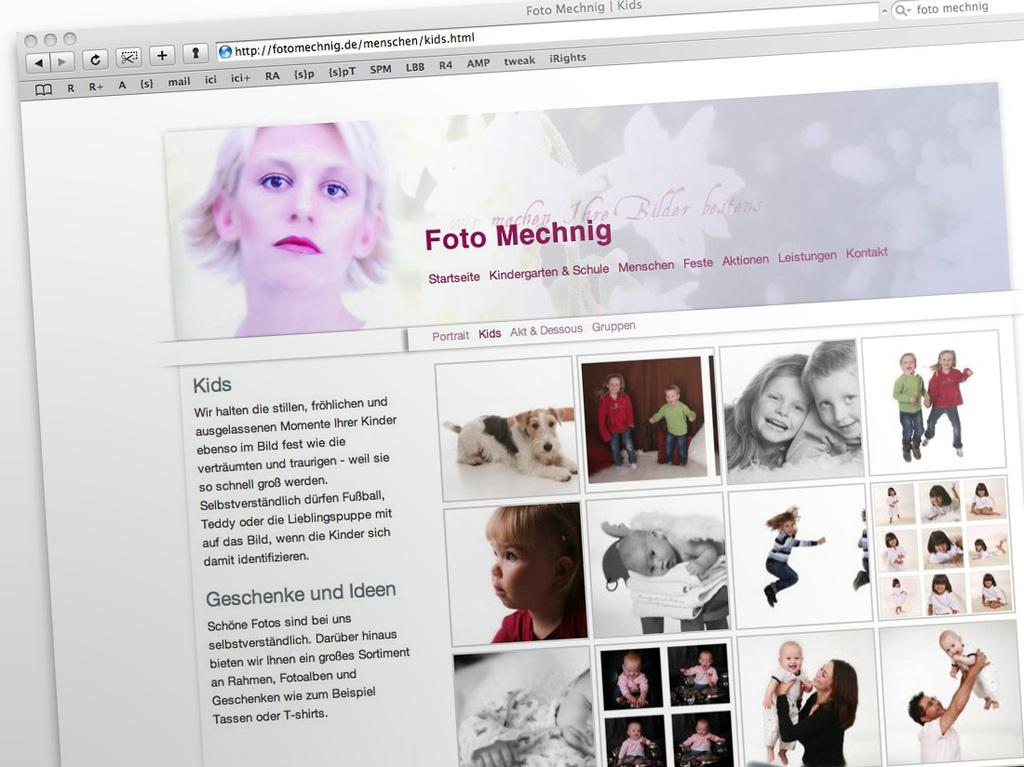What type of image is this? The image is a screenshot of a web page. What elements can be found on the web page? The web page contains text and pictures. What type of caption is present under the tree in the image? There is no tree or caption present in the image, as it is a screenshot of a web page. Where is the store located in the image? There is no store present in the image, as it is a screenshot of a web page. 